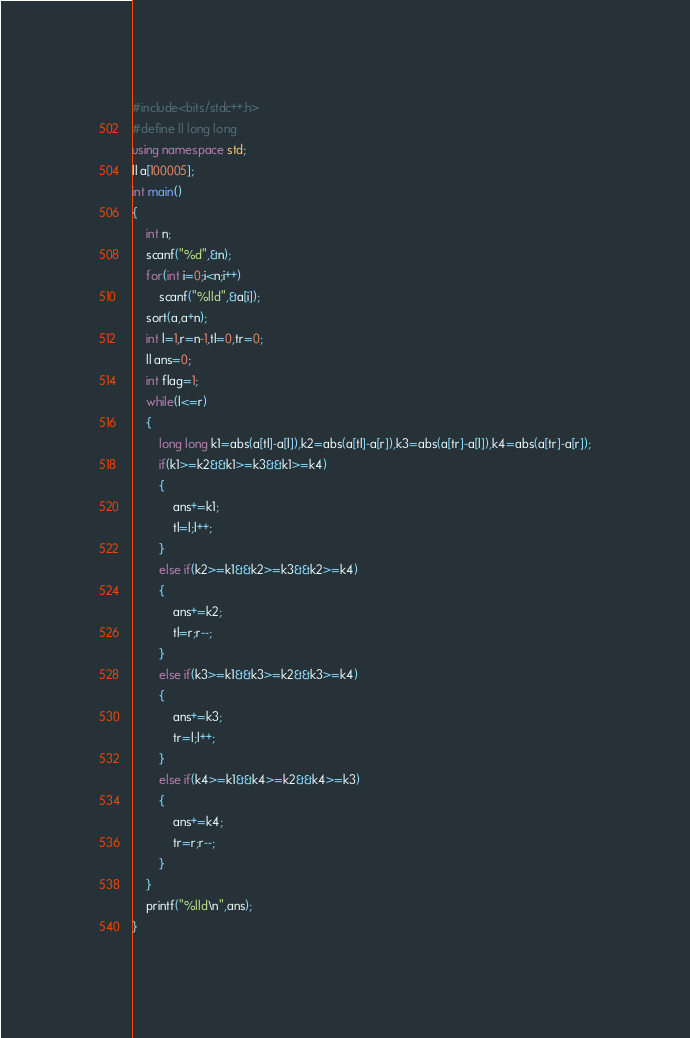<code> <loc_0><loc_0><loc_500><loc_500><_C++_>#include<bits/stdc++.h>
#define ll long long
using namespace std;
ll a[100005];
int main()
{
    int n;
    scanf("%d",&n);
    for(int i=0;i<n;i++)
        scanf("%lld",&a[i]);
    sort(a,a+n);
    int l=1,r=n-1,tl=0,tr=0;
    ll ans=0;
    int flag=1;
    while(l<=r)
    {
        long long k1=abs(a[tl]-a[l]),k2=abs(a[tl]-a[r]),k3=abs(a[tr]-a[l]),k4=abs(a[tr]-a[r]);
        if(k1>=k2&&k1>=k3&&k1>=k4)
        {
            ans+=k1;
            tl=l;l++;
        }
        else if(k2>=k1&&k2>=k3&&k2>=k4)
        {
            ans+=k2;
            tl=r;r--;
        }
        else if(k3>=k1&&k3>=k2&&k3>=k4)
        {
            ans+=k3;
            tr=l;l++;
        }
        else if(k4>=k1&&k4>=k2&&k4>=k3)
        {
            ans+=k4;
            tr=r;r--;
        }
    }
    printf("%lld\n",ans);
}
</code> 